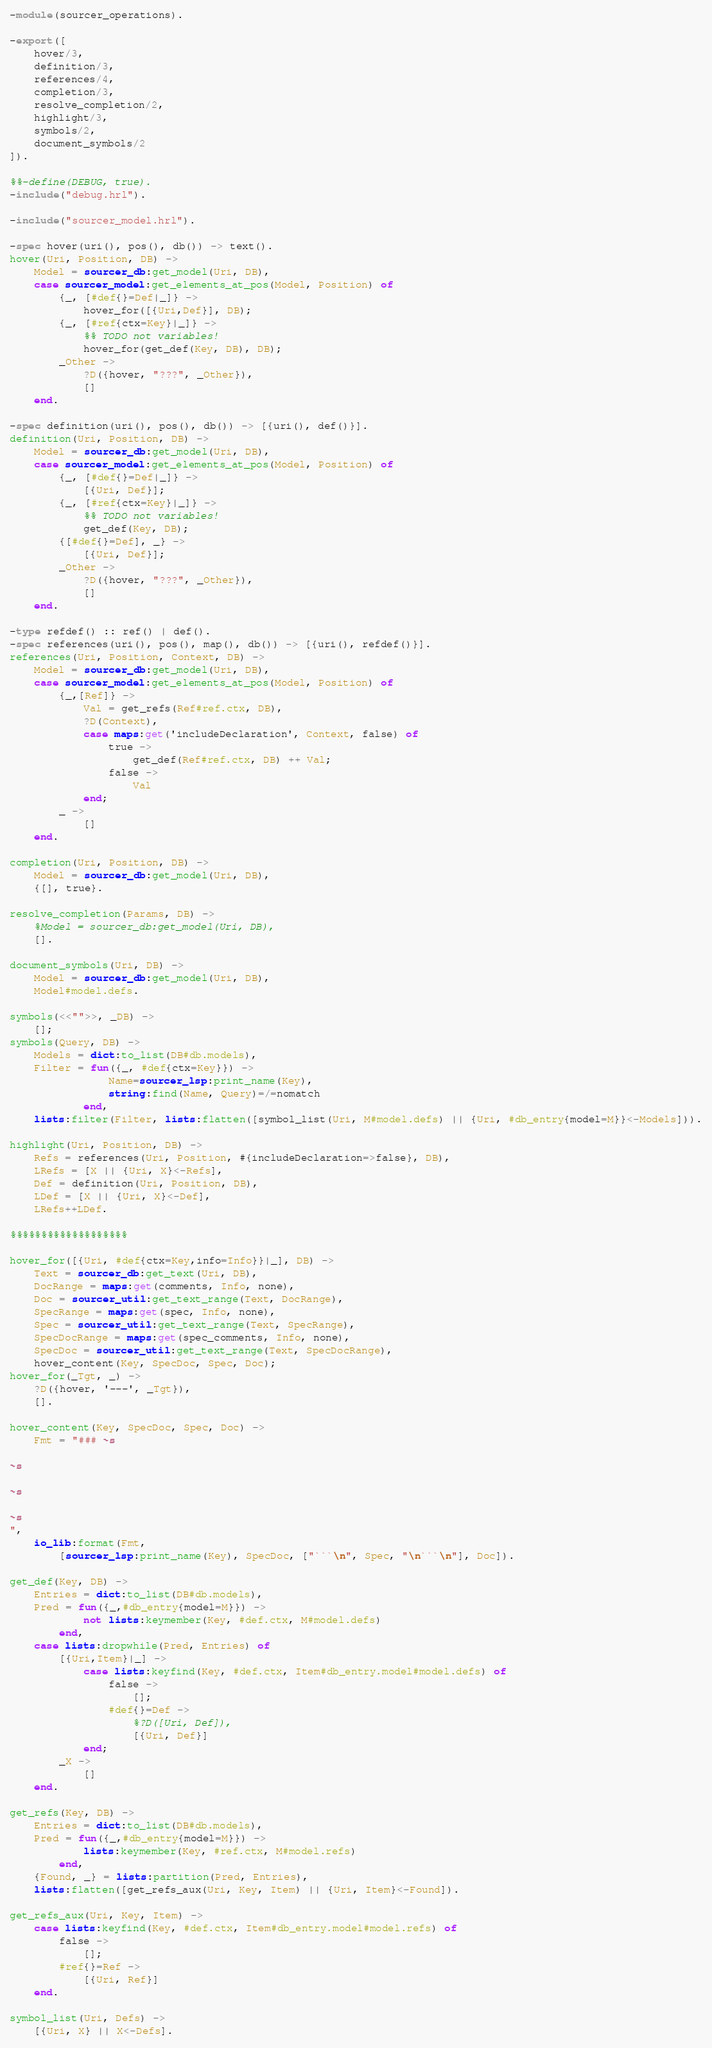Convert code to text. <code><loc_0><loc_0><loc_500><loc_500><_Erlang_>-module(sourcer_operations).

-export([
    hover/3,
    definition/3,
    references/4,
    completion/3,
    resolve_completion/2,
    highlight/3,
    symbols/2,
    document_symbols/2
]).

%%-define(DEBUG, true).
-include("debug.hrl").

-include("sourcer_model.hrl").

-spec hover(uri(), pos(), db()) -> text().
hover(Uri, Position, DB) ->
    Model = sourcer_db:get_model(Uri, DB),
    case sourcer_model:get_elements_at_pos(Model, Position) of
        {_, [#def{}=Def|_]} ->
            hover_for([{Uri,Def}], DB);
        {_, [#ref{ctx=Key}|_]} ->
            %% TODO not variables!
            hover_for(get_def(Key, DB), DB); 
        _Other ->
            ?D({hover, "???", _Other}),
            []
    end.

-spec definition(uri(), pos(), db()) -> [{uri(), def()}].
definition(Uri, Position, DB) ->
    Model = sourcer_db:get_model(Uri, DB),
    case sourcer_model:get_elements_at_pos(Model, Position) of 
        {_, [#def{}=Def|_]} ->
            [{Uri, Def}];
        {_, [#ref{ctx=Key}|_]} ->
            %% TODO not variables!
            get_def(Key, DB); 
        {[#def{}=Def], _} ->
            [{Uri, Def}];
        _Other ->
            ?D({hover, "???", _Other}),
            []
    end.

-type refdef() :: ref() | def().
-spec references(uri(), pos(), map(), db()) -> [{uri(), refdef()}].
references(Uri, Position, Context, DB) ->
    Model = sourcer_db:get_model(Uri, DB),
    case sourcer_model:get_elements_at_pos(Model, Position) of
        {_,[Ref]} ->
            Val = get_refs(Ref#ref.ctx, DB),
            ?D(Context),
            case maps:get('includeDeclaration', Context, false) of
                true ->
                    get_def(Ref#ref.ctx, DB) ++ Val;
                false ->
                    Val
            end;
        _ ->
            []
    end.

completion(Uri, Position, DB) ->
    Model = sourcer_db:get_model(Uri, DB),
    {[], true}.

resolve_completion(Params, DB) ->
    %Model = sourcer_db:get_model(Uri, DB),
    [].

document_symbols(Uri, DB) ->
    Model = sourcer_db:get_model(Uri, DB),
    Model#model.defs.

symbols(<<"">>, _DB) ->
    [];
symbols(Query, DB) ->
    Models = dict:to_list(DB#db.models),
    Filter = fun({_, #def{ctx=Key}}) -> 
                Name=sourcer_lsp:print_name(Key), 
                string:find(Name, Query)=/=nomatch
            end,
    lists:filter(Filter, lists:flatten([symbol_list(Uri, M#model.defs) || {Uri, #db_entry{model=M}}<-Models])).

highlight(Uri, Position, DB) ->
    Refs = references(Uri, Position, #{includeDeclaration=>false}, DB),
    LRefs = [X || {Uri, X}<-Refs],
    Def = definition(Uri, Position, DB),
    LDef = [X || {Uri, X}<-Def],
    LRefs++LDef.

%%%%%%%%%%%%%%%%%%%

hover_for([{Uri, #def{ctx=Key,info=Info}}|_], DB) ->
    Text = sourcer_db:get_text(Uri, DB),
    DocRange = maps:get(comments, Info, none),
    Doc = sourcer_util:get_text_range(Text, DocRange),
    SpecRange = maps:get(spec, Info, none),
    Spec = sourcer_util:get_text_range(Text, SpecRange),
    SpecDocRange = maps:get(spec_comments, Info, none),
    SpecDoc = sourcer_util:get_text_range(Text, SpecDocRange),
    hover_content(Key, SpecDoc, Spec, Doc);
hover_for(_Tgt, _) ->
    ?D({hover, '---', _Tgt}),
    [].

hover_content(Key, SpecDoc, Spec, Doc) ->
    Fmt = "### ~s

~s

~s

~s
",
    io_lib:format(Fmt, 
        [sourcer_lsp:print_name(Key), SpecDoc, ["```\n", Spec, "\n```\n"], Doc]).

get_def(Key, DB) ->
    Entries = dict:to_list(DB#db.models),
    Pred = fun({_,#db_entry{model=M}}) -> 
            not lists:keymember(Key, #def.ctx, M#model.defs) 
        end,
    case lists:dropwhile(Pred, Entries) of
        [{Uri,Item}|_] ->
            case lists:keyfind(Key, #def.ctx, Item#db_entry.model#model.defs) of
                false ->
                    [];
                #def{}=Def ->
                    %?D([Uri, Def]),
                    [{Uri, Def}]
            end;
        _X ->
            []
    end.

get_refs(Key, DB) ->
    Entries = dict:to_list(DB#db.models),
    Pred = fun({_,#db_entry{model=M}}) -> 
            lists:keymember(Key, #ref.ctx, M#model.refs) 
        end,
    {Found, _} = lists:partition(Pred, Entries),
    lists:flatten([get_refs_aux(Uri, Key, Item) || {Uri, Item}<-Found]).

get_refs_aux(Uri, Key, Item) ->
    case lists:keyfind(Key, #def.ctx, Item#db_entry.model#model.refs) of
        false ->
            [];
        #ref{}=Ref ->
            [{Uri, Ref}]
    end.

symbol_list(Uri, Defs) ->
    [{Uri, X} || X<-Defs].</code> 